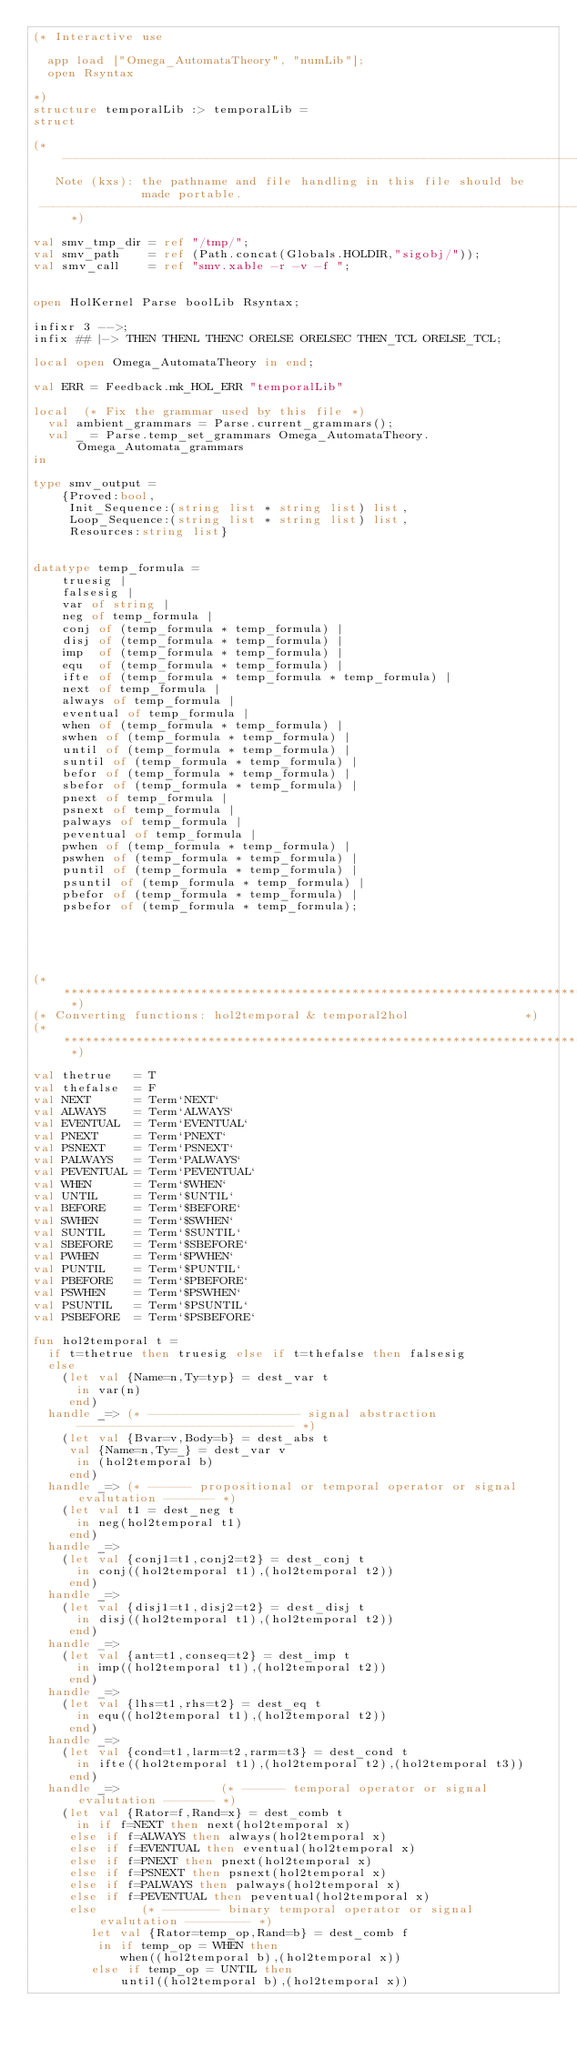<code> <loc_0><loc_0><loc_500><loc_500><_SML_>(* Interactive use

  app load ["Omega_AutomataTheory", "numLib"];
  open Rsyntax

*)
structure temporalLib :> temporalLib =
struct

(*---------------------------------------------------------------------------
   Note (kxs): the pathname and file handling in this file should be
               made portable.
 ---------------------------------------------------------------------------*)

val smv_tmp_dir = ref "/tmp/";
val smv_path    = ref (Path.concat(Globals.HOLDIR,"sigobj/"));
val smv_call    = ref "smv.xable -r -v -f ";


open HolKernel Parse boolLib Rsyntax;

infixr 3 -->;
infix ## |-> THEN THENL THENC ORELSE ORELSEC THEN_TCL ORELSE_TCL;

local open Omega_AutomataTheory in end;

val ERR = Feedback.mk_HOL_ERR "temporalLib"

local  (* Fix the grammar used by this file *)
  val ambient_grammars = Parse.current_grammars();
  val _ = Parse.temp_set_grammars Omega_AutomataTheory.Omega_Automata_grammars
in

type smv_output =
	{Proved:bool,
	 Init_Sequence:(string list * string list) list,
	 Loop_Sequence:(string list * string list) list,
	 Resources:string list}


datatype temp_formula =
	truesig |
	falsesig |
	var of string |
	neg of temp_formula |
	conj of (temp_formula * temp_formula) |
	disj of (temp_formula * temp_formula) |
	imp  of (temp_formula * temp_formula) |
	equ  of (temp_formula * temp_formula) |
	ifte of (temp_formula * temp_formula * temp_formula) |
	next of temp_formula |
	always of temp_formula |
	eventual of temp_formula |
	when of (temp_formula * temp_formula) |
	swhen of (temp_formula * temp_formula) |
	until of (temp_formula * temp_formula) |
	suntil of (temp_formula * temp_formula) |
	befor of (temp_formula * temp_formula) |
	sbefor of (temp_formula * temp_formula) |
	pnext of temp_formula |
	psnext of temp_formula |
	palways of temp_formula |
	peventual of temp_formula |
	pwhen of (temp_formula * temp_formula) |
	pswhen of (temp_formula * temp_formula) |
	puntil of (temp_formula * temp_formula) |
	psuntil of (temp_formula * temp_formula) |
	pbefor of (temp_formula * temp_formula) |
	psbefor of (temp_formula * temp_formula);





(* ****************************************************************************	*)
(* Converting functions: hol2temporal & temporal2hol				*)
(* ****************************************************************************	*)

val thetrue   = T
val thefalse  = F
val NEXT      = Term`NEXT`
val ALWAYS    = Term`ALWAYS`
val EVENTUAL  = Term`EVENTUAL`
val PNEXT     = Term`PNEXT`
val PSNEXT    = Term`PSNEXT`
val PALWAYS   = Term`PALWAYS`
val PEVENTUAL = Term`PEVENTUAL`
val WHEN      = Term`$WHEN`
val UNTIL     = Term`$UNTIL`
val BEFORE    = Term`$BEFORE`
val SWHEN     = Term`$SWHEN`
val SUNTIL    = Term`$SUNTIL`
val SBEFORE   = Term`$SBEFORE`
val PWHEN     = Term`$PWHEN`
val PUNTIL    = Term`$PUNTIL`
val PBEFORE   = Term`$PBEFORE`
val PSWHEN    = Term`$PSWHEN`
val PSUNTIL   = Term`$PSUNTIL`
val PSBEFORE  = Term`$PSBEFORE`

fun hol2temporal t =
  if t=thetrue then truesig else if t=thefalse then falsesig
  else
    (let val {Name=n,Ty=typ} = dest_var t
      in var(n)
     end)
  handle _=> (* --------------------- signal abstraction ------------------------------	*)
    (let val {Bvar=v,Body=b} = dest_abs t
	 val {Name=n,Ty=_} = dest_var v
      in (hol2temporal b)
     end)
  handle _=> (* ------ propositional or temporal operator or signal evalutation -------	*)
    (let val t1 = dest_neg t
      in neg(hol2temporal t1)
     end)
  handle _=>
    (let val {conj1=t1,conj2=t2} = dest_conj t
      in conj((hol2temporal t1),(hol2temporal t2))
     end)
  handle _=>
    (let val {disj1=t1,disj2=t2} = dest_disj t
      in disj((hol2temporal t1),(hol2temporal t2))
     end)
  handle _=>
    (let val {ant=t1,conseq=t2} = dest_imp t
      in imp((hol2temporal t1),(hol2temporal t2))
     end)
  handle _=>
    (let val {lhs=t1,rhs=t2} = dest_eq t
      in equ((hol2temporal t1),(hol2temporal t2))
     end)
  handle _=>
    (let val {cond=t1,larm=t2,rarm=t3} = dest_cond t
      in ifte((hol2temporal t1),(hol2temporal t2),(hol2temporal t3))
     end)
  handle _=> 		      (* ------ temporal operator or signal evalutation -------	*)
    (let val {Rator=f,Rand=x} = dest_comb t
      in if f=NEXT then next(hol2temporal x)
	 else if f=ALWAYS then always(hol2temporal x)
	 else if f=EVENTUAL then eventual(hol2temporal x)
	 else if f=PNEXT then pnext(hol2temporal x)
	 else if f=PSNEXT then psnext(hol2temporal x)
	 else if f=PALWAYS then palways(hol2temporal x)
	 else if f=PEVENTUAL then peventual(hol2temporal x)
	 else      (* -------- binary temporal operator or signal evalutation ---------	*)
	    let val {Rator=temp_op,Rand=b} = dest_comb f
	     in if temp_op = WHEN then
			when((hol2temporal b),(hol2temporal x))
		else if temp_op = UNTIL then
			until((hol2temporal b),(hol2temporal x))</code> 